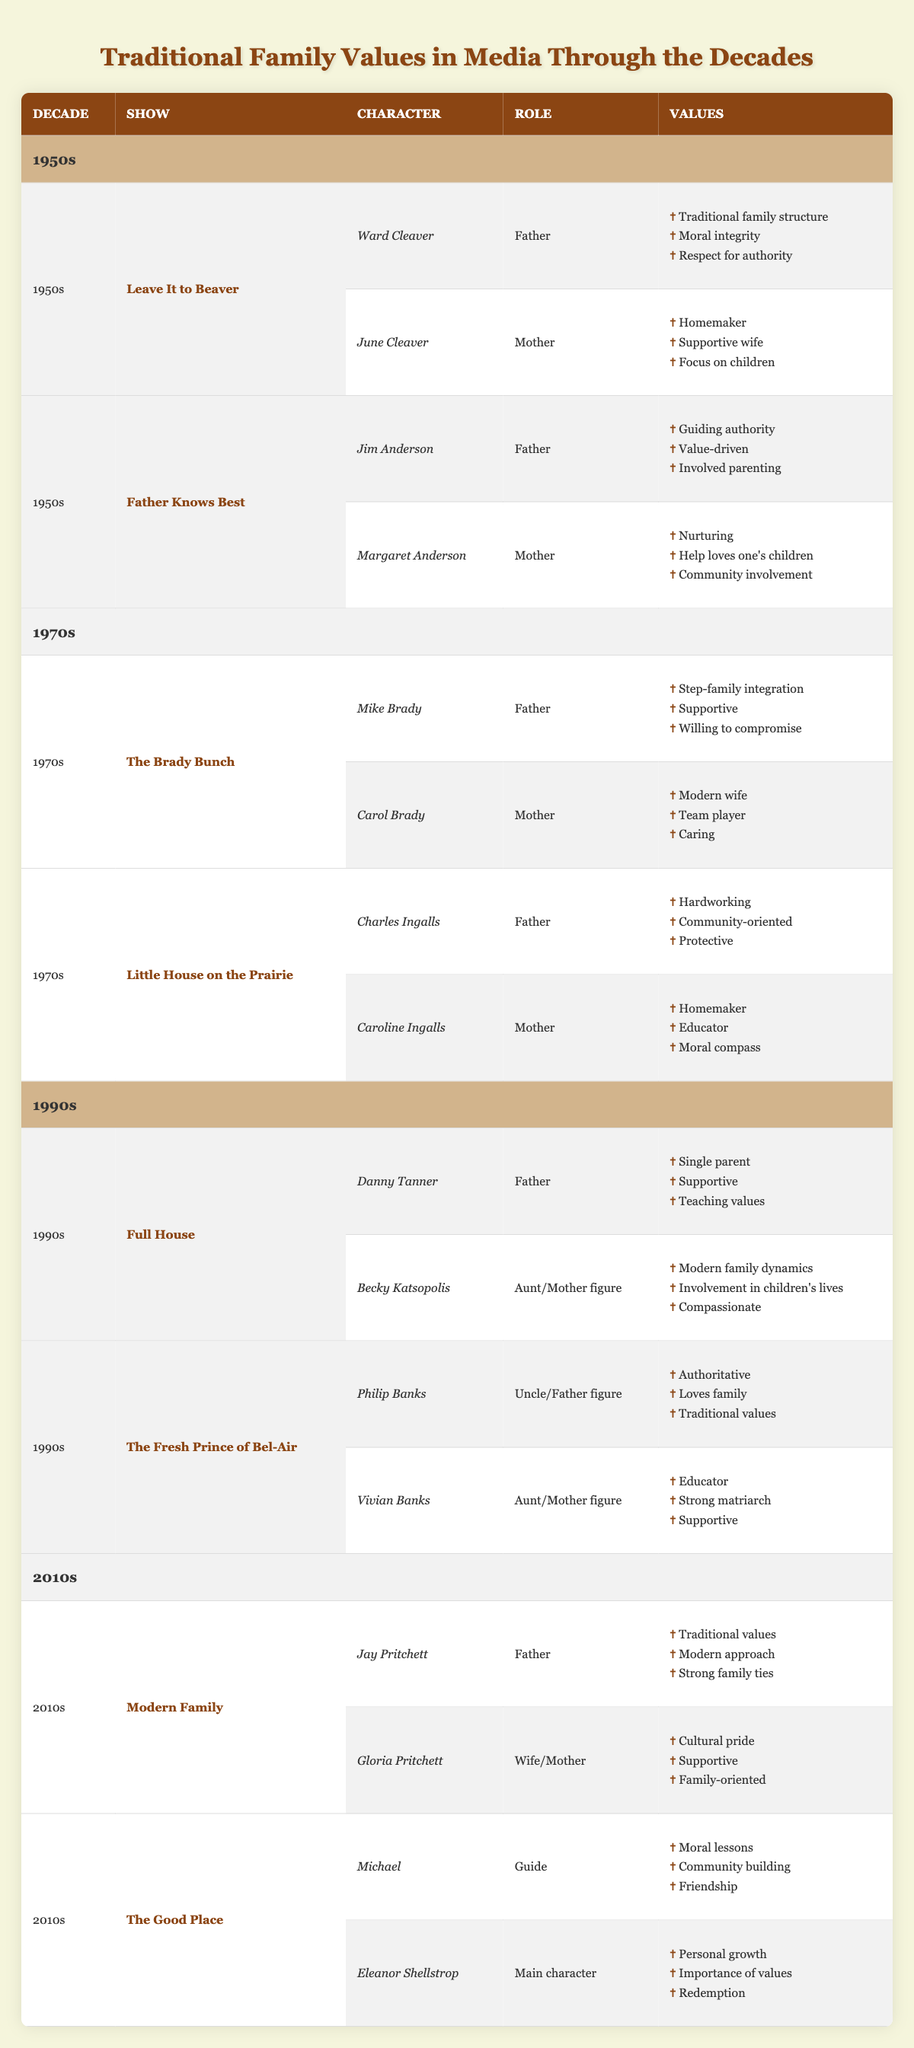What television show features the character Ward Cleaver? Ward Cleaver is a character from the show "Leave It to Beaver" in the 1950s. This can be found directly by looking at the respective decade and show in the table.
Answer: Leave It to Beaver How many characters in the 1990s shows are depicted as father figures? In the 1990s, both "Full House" (Danny Tanner) and "The Fresh Prince of Bel-Air" (Philip Banks) feature father figures. Hence, there are two characters fulfilling this role from the table.
Answer: 2 Did the character Mike Brady show a willingness to compromise? According to the table, Mike Brady from "The Brady Bunch" is described as "Willing to compromise," which confirms that this fact is true.
Answer: Yes Identify the values associated with the character Caroline Ingalls. From the table, Caroline Ingalls, who is depicted as a mother figure in "Little House on the Prairie," has the values of "Homemaker," "Educator," and "Moral compass." These can be directly retrieved from her row.
Answer: Homemaker, Educator, Moral compass Which decade has characters with a focus on both traditional and modern family values? In the 2010s, the show "Modern Family" features characters Jay Pritchett and Gloria Pritchett who embody traditional values and a modern approach. This shows a blending of values from the table.
Answer: 2010s What is the role of Eleanor Shellstrop in "The Good Place"? Eleanor Shellstrop is identified as the "Main character" in "The Good Place." This can be easily looked up in the respective decade and show rows in the table.
Answer: Main character How many media entries in the 1970s feature characters with community-oriented values? In the 1970s shows, "Little House on the Prairie" has Charles Ingalls listed as "Community-oriented." Therefore, there is one entry in this decade with this value.
Answer: 1 Did any character in the 1950s shows exemplify respect for authority? The character Ward Cleaver from "Leave It to Beaver" is attributed with the value of "Respect for authority," making this fact true.
Answer: Yes Which shows from the 1990s depict single parenting? The show "Full House" features Danny Tanner as a single parent, confirmed by the respective entry in the table.
Answer: Full House 